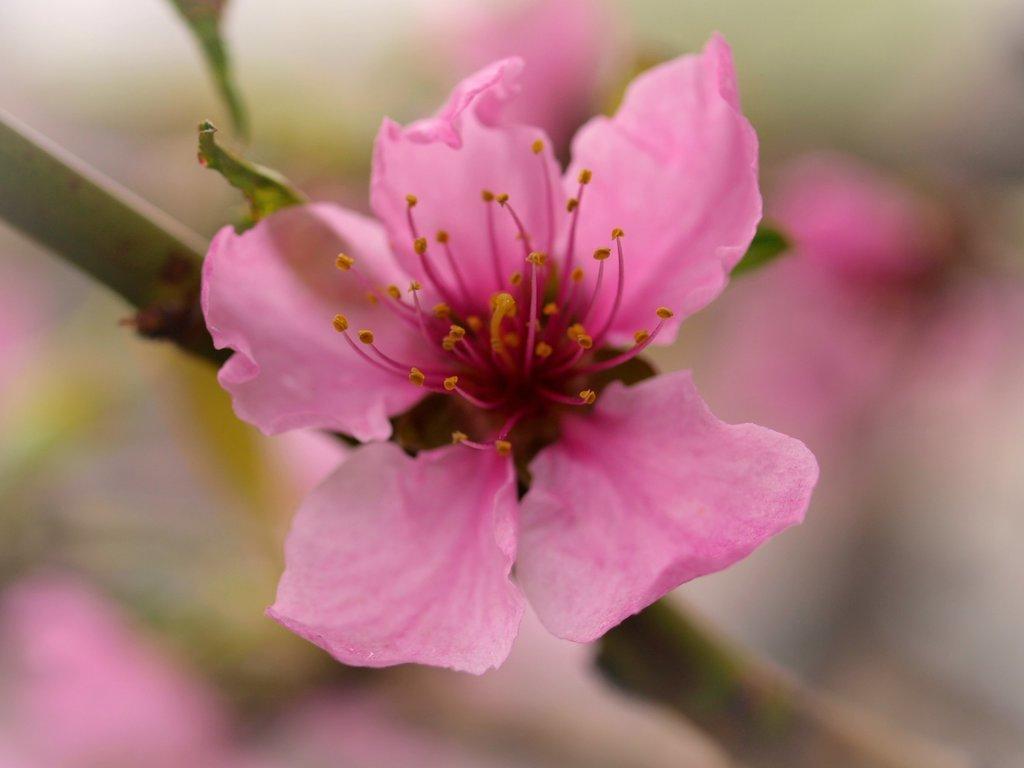In one or two sentences, can you explain what this image depicts? In this image, I can see a flower, which is pink in color. This is the stem. The background looks blurry. 